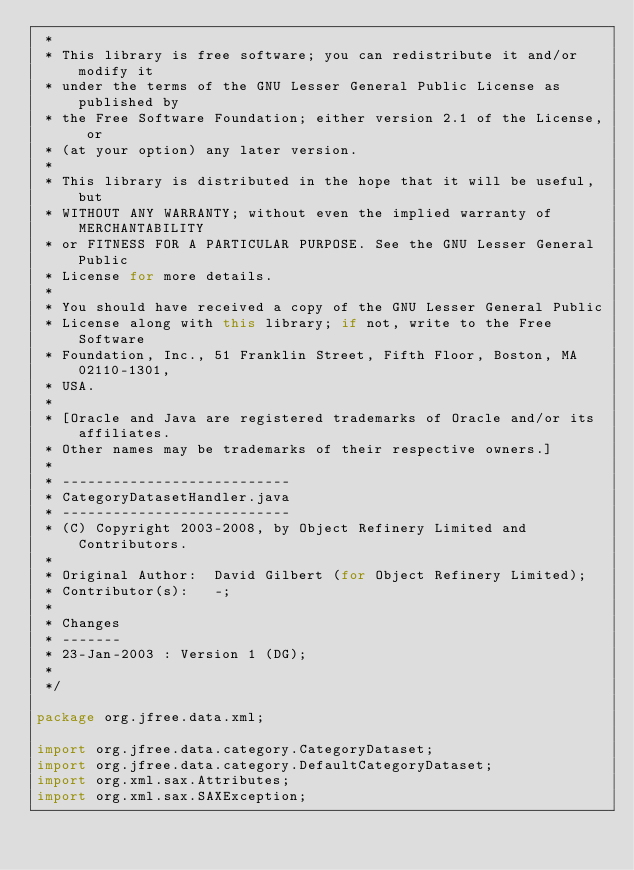Convert code to text. <code><loc_0><loc_0><loc_500><loc_500><_Java_> *
 * This library is free software; you can redistribute it and/or modify it
 * under the terms of the GNU Lesser General Public License as published by
 * the Free Software Foundation; either version 2.1 of the License, or
 * (at your option) any later version.
 *
 * This library is distributed in the hope that it will be useful, but
 * WITHOUT ANY WARRANTY; without even the implied warranty of MERCHANTABILITY
 * or FITNESS FOR A PARTICULAR PURPOSE. See the GNU Lesser General Public
 * License for more details.
 *
 * You should have received a copy of the GNU Lesser General Public
 * License along with this library; if not, write to the Free Software
 * Foundation, Inc., 51 Franklin Street, Fifth Floor, Boston, MA  02110-1301,
 * USA.
 *
 * [Oracle and Java are registered trademarks of Oracle and/or its affiliates. 
 * Other names may be trademarks of their respective owners.]
 *
 * ---------------------------
 * CategoryDatasetHandler.java
 * ---------------------------
 * (C) Copyright 2003-2008, by Object Refinery Limited and Contributors.
 *
 * Original Author:  David Gilbert (for Object Refinery Limited);
 * Contributor(s):   -;
 *
 * Changes
 * -------
 * 23-Jan-2003 : Version 1 (DG);
 *
 */

package org.jfree.data.xml;

import org.jfree.data.category.CategoryDataset;
import org.jfree.data.category.DefaultCategoryDataset;
import org.xml.sax.Attributes;
import org.xml.sax.SAXException;</code> 